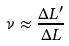Convert formula to latex. <formula><loc_0><loc_0><loc_500><loc_500>\nu \approx \frac { \Delta L ^ { \prime } } { \Delta L }</formula> 